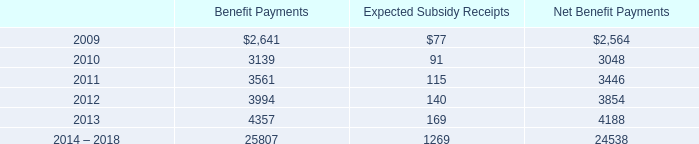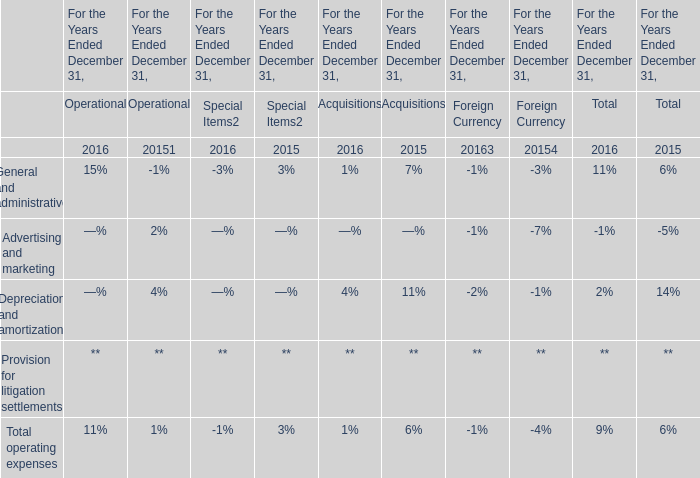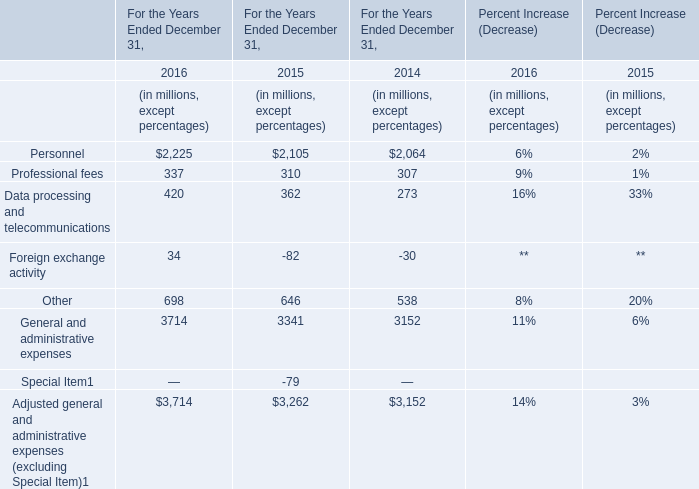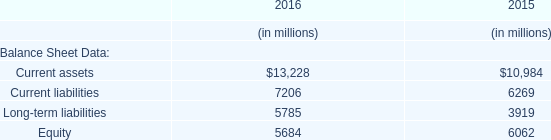What was the amount of the Professional fees in the year where General and administrative expenses is the largest? (in million) 
Answer: 337. 